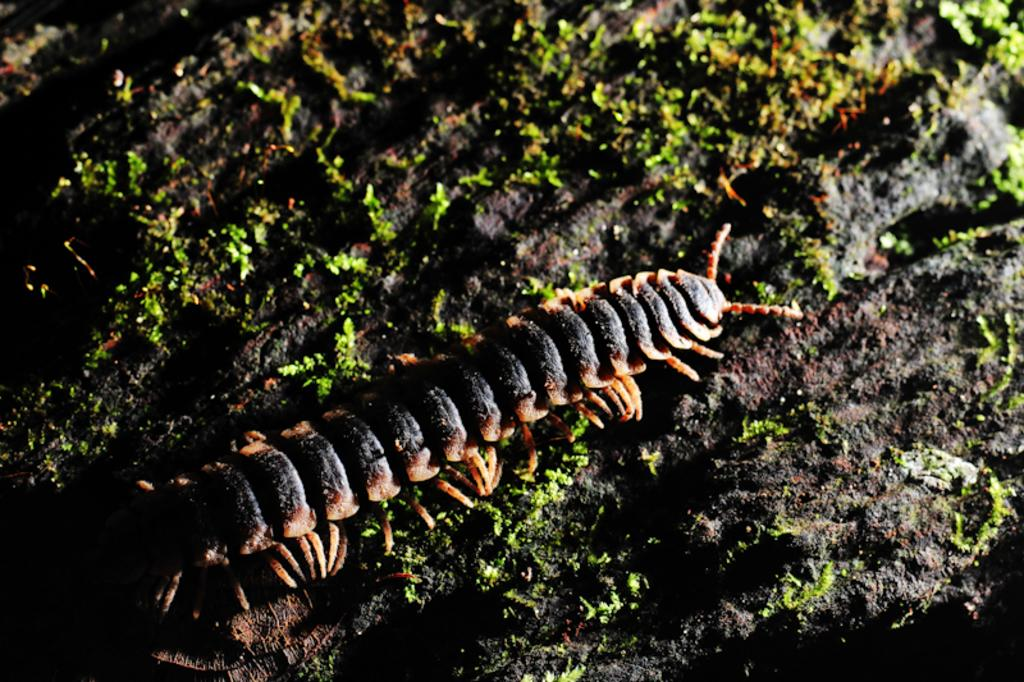What type of creature is present in the image? There is a millipede in the image. What other object can be seen in the image? There is a rock with algae in the image. What type of chair is visible in the image? There is no chair present in the image. What holiday is being celebrated in the image? There is no indication of a holiday being celebrated in the image. 